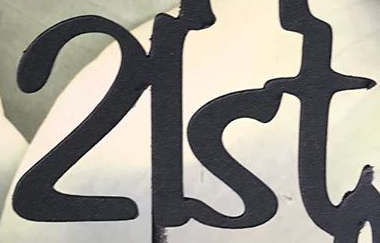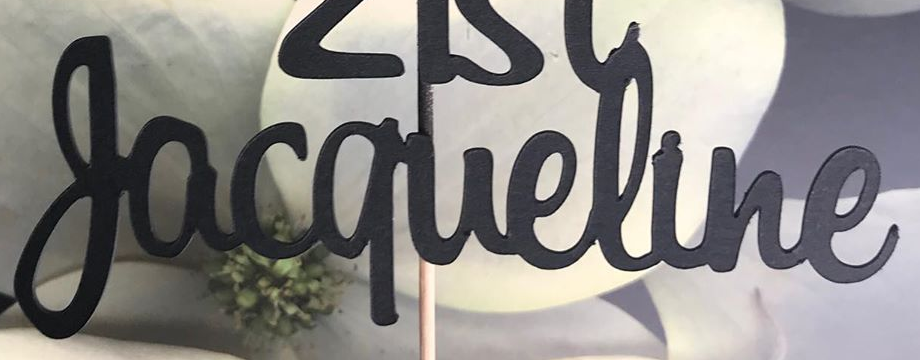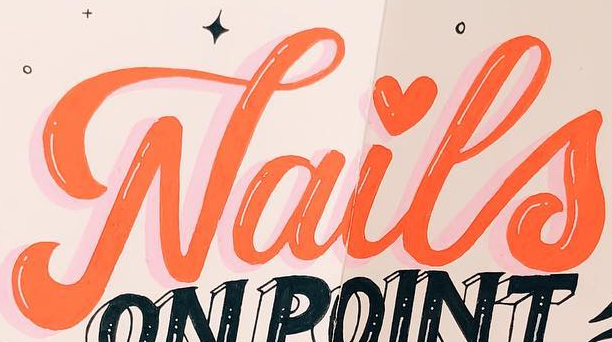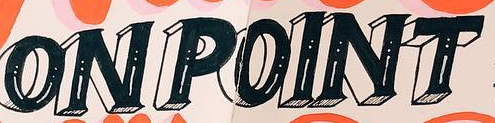Identify the words shown in these images in order, separated by a semicolon. 21st; Jacqueline; Nails; ONPOINT 